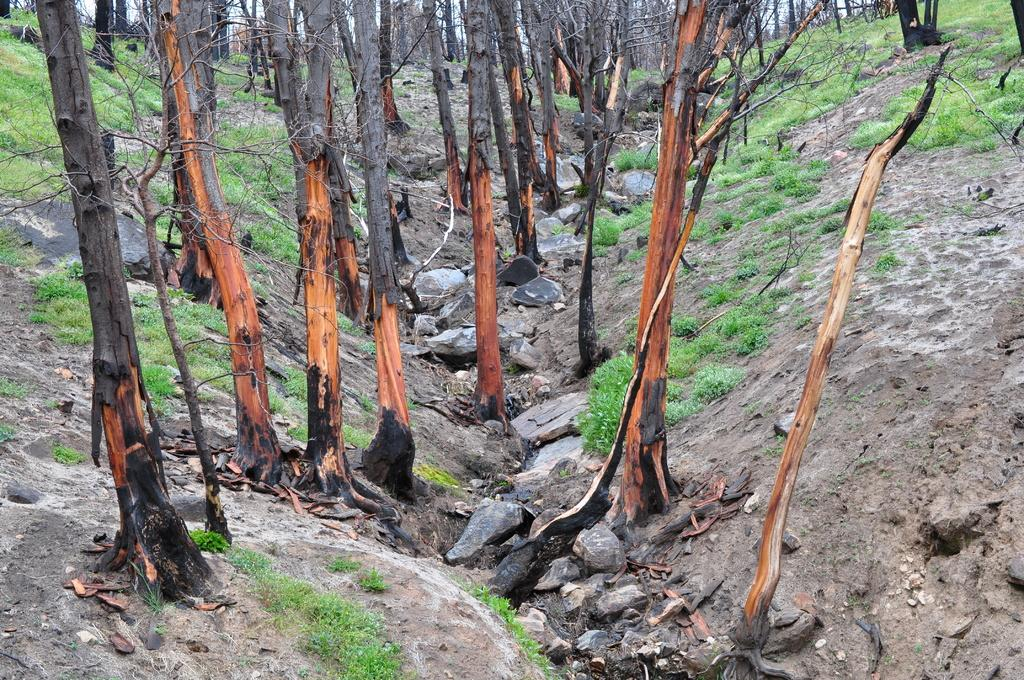What type of vegetation can be seen in the image? There are dry trees in the image. What else can be seen on the surface of the area in the image? There is grass on the surface of the area in the image. How many legs can be seen on the girls in the image? There are no girls present in the image, so it is not possible to determine the number of legs they might have. 